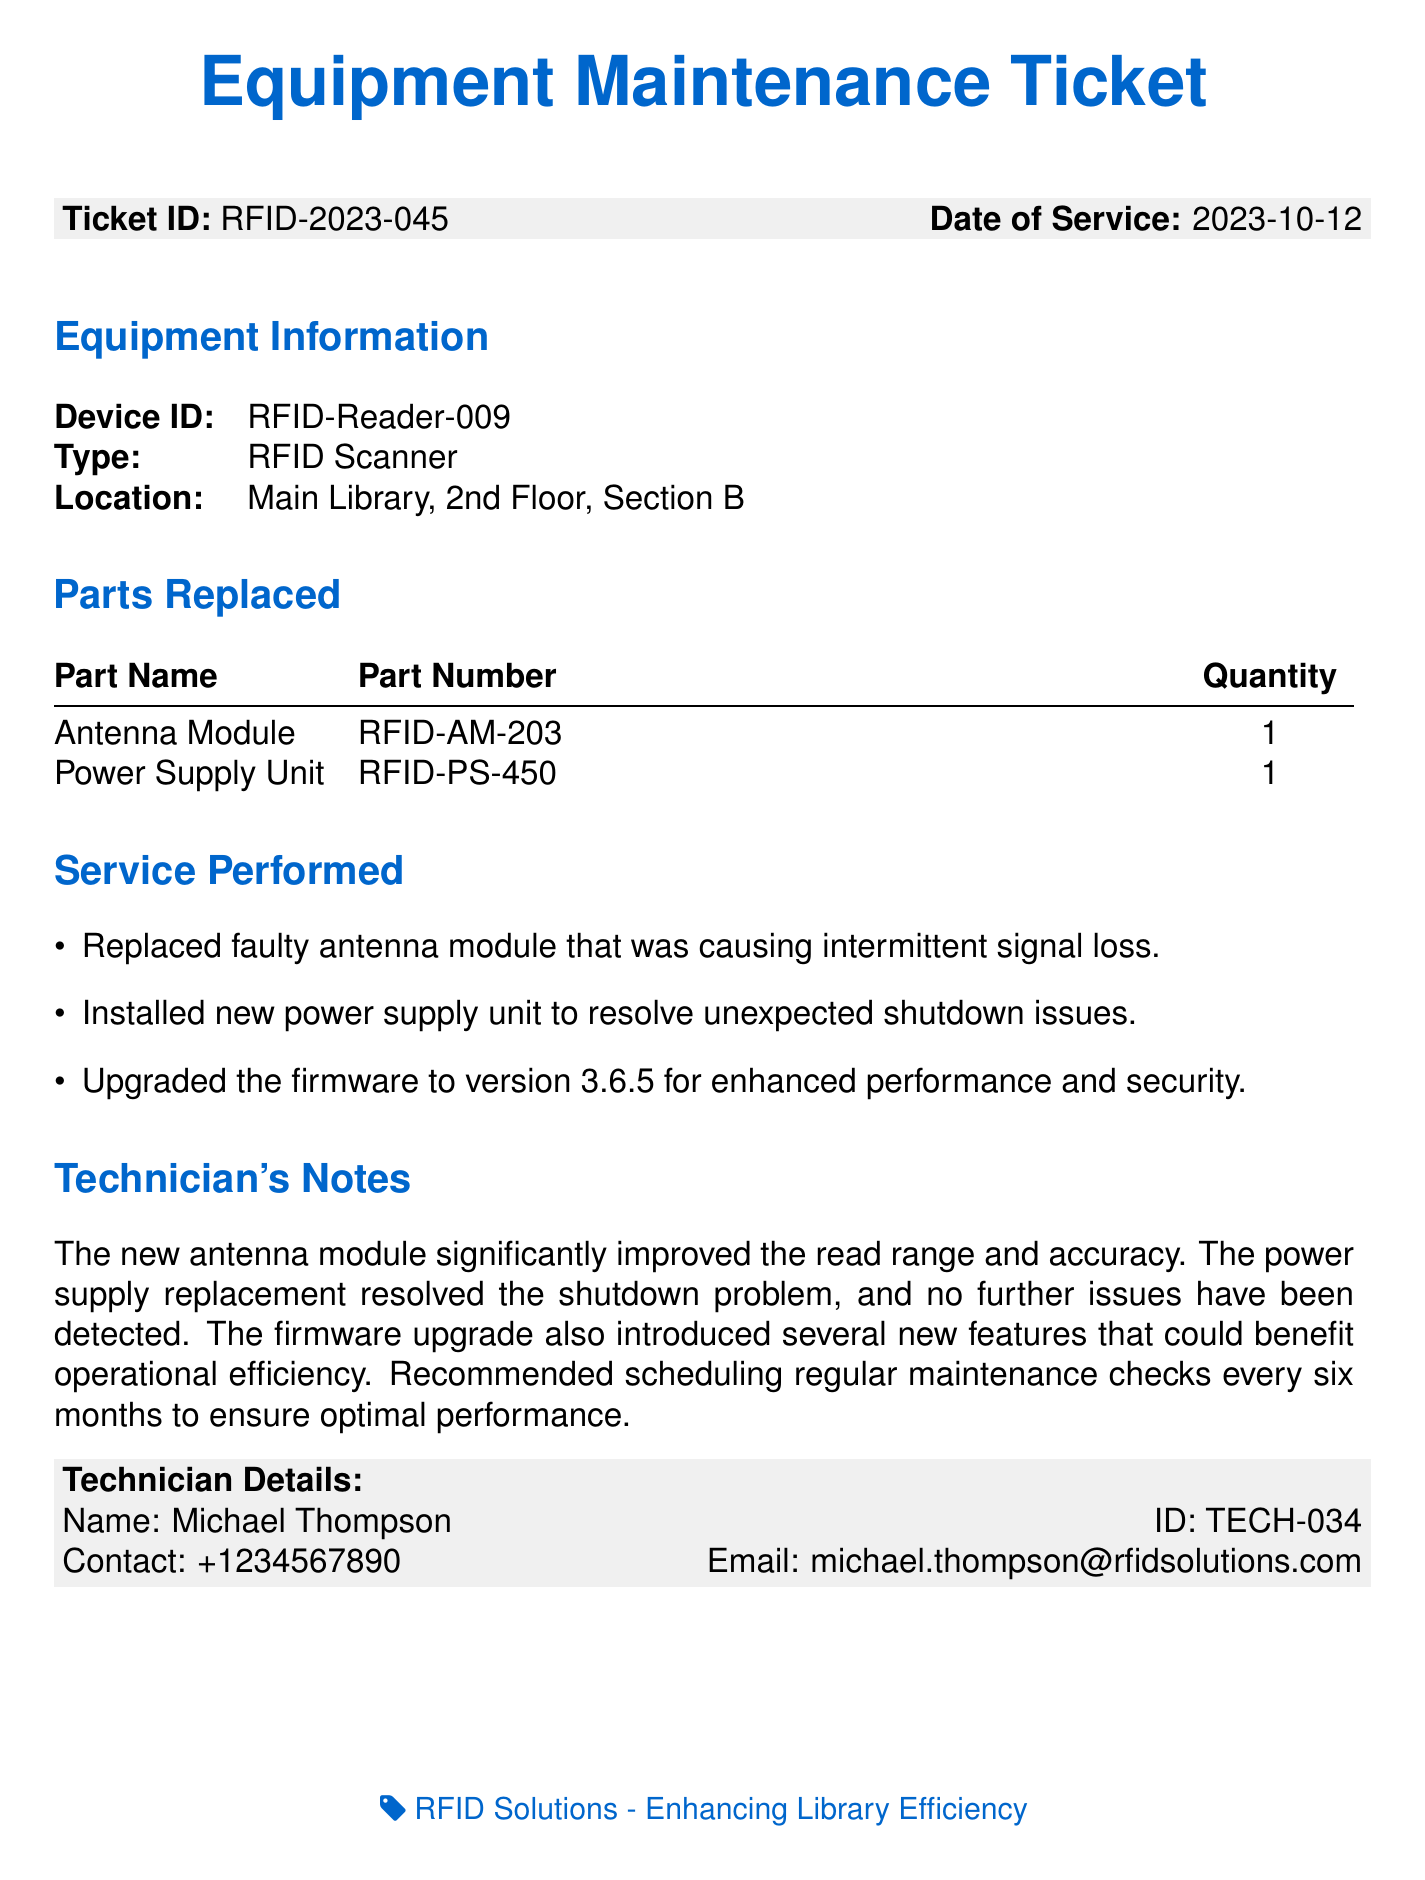What is the ticket ID? The ticket ID is listed prominently at the top of the document under the ticket information section.
Answer: RFID-2023-045 When was the service performed? The date of service is provided right next to the ticket ID in the document.
Answer: 2023-10-12 What devices were serviced? The document details the specific device information including the device ID and type of equipment serviced.
Answer: RFID-Reader-009, RFID Scanner Which parts were replaced? The parts replaced are detailed in the corresponding section with their names and quantities.
Answer: Antenna Module, Power Supply Unit What did the technician recommend? The technician's notes section includes recommendations for future maintenance and checks.
Answer: Regular maintenance checks every six months Who performed the service? The technician's details are provided at the end of the document, listing the technician's name and ID.
Answer: Michael Thompson What was the main issue with the antenna module? The service performed section states the specific issue that led to the repair of the antenna module.
Answer: Intermittent signal loss How many power supply units were replaced? The document specifies the quantity of the power supply unit replaced in the parts replaced section.
Answer: 1 What firmware version was installed? The service performed section mentions the new firmware version utilized during the service.
Answer: 3.6.5 